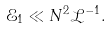Convert formula to latex. <formula><loc_0><loc_0><loc_500><loc_500>\mathcal { E } _ { 1 } \ll N ^ { 2 } \mathcal { L } ^ { - 1 } .</formula> 